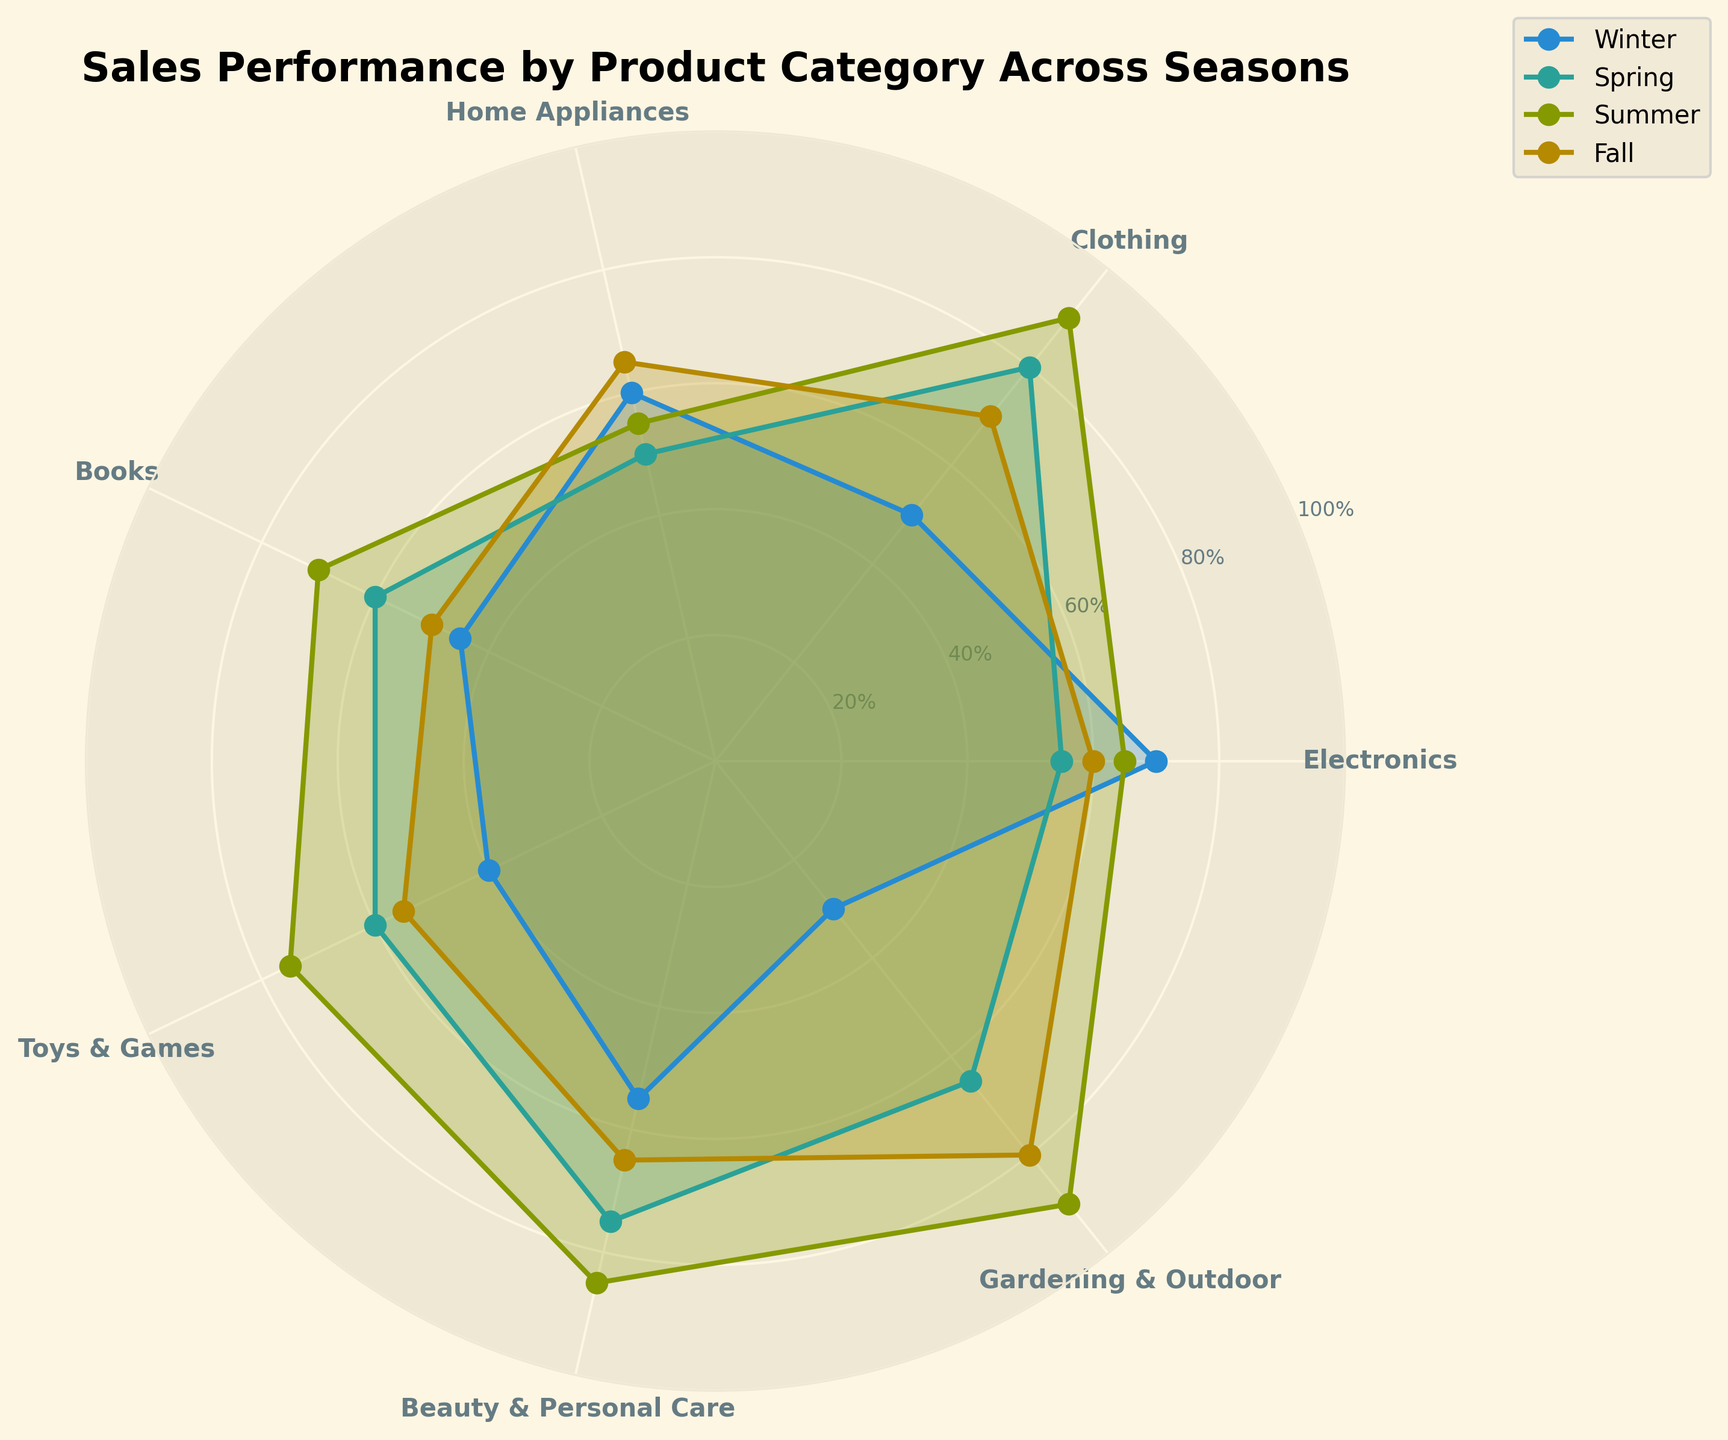What's the title of the radar chart? The title of the radar chart is located at the top center of the figure.
Answer: Sales Performance by Product Category Across Seasons How many product categories are plotted on the radar chart? Count the number of categories listed around the perimeter of the radar chart.
Answer: 7 Which product category has the highest sales performance in the Summer? Locate the data point for each category specific to the Summer season and identify the highest one.
Answer: Gardening & Outdoor In which season does the 'Beauty & Personal Care' category have its highest sales performance? Compare the values of the 'Beauty & Personal Care' category across all four seasons to determine the highest one.
Answer: Summer What is the average sales performance for 'Electronics' across all seasons? Calculate the average of the values for the 'Electronics' category: (70 + 55 + 65 + 60) / 4.
Answer: 62.5 Which season shows the most significant increase in sales for the 'Clothing' category compared to Winter? Compare the sales values for 'Clothing' in Spring, Summer, and Fall with its value in Winter. The most significant increase is determined by finding the largest difference.
Answer: Summer What is the sales performance difference between 'Home Appliances' and 'Toys & Games' in Fall? Subtract the Fall sales value of 'Home Appliances' from that of 'Toys & Games': 55 - 65.
Answer: 10 Which product category shows the least variation in sales performance across the seasons? Determine the category with the smallest range (difference between the maximum and minimum values) of sales performance across all seasons.
Answer: Electronics What's the median sales performance for 'Books' across all seasons? Sort the sales values for 'Books' (45, 60, 70, 50) and find the median (the middle value in the ordered list). The sorted list is 45, 50, 60, 70; the median is the average of 50 and 60.
Answer: 55 Between 'Winter' and 'Fall', which season has higher average sales performance across all product categories? Calculate the average sales performance for each season separately and compare them. For Winter: (70+50+60+45+40+55+30)/7. For Fall: (60+70+65+50+55+65+80)/7. Comparisons yield averages of 50 for Winter and 63.57 for Fall.
Answer: Fall 